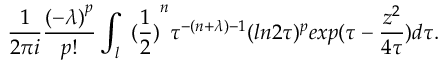Convert formula to latex. <formula><loc_0><loc_0><loc_500><loc_500>\frac { 1 } { 2 \pi i } \frac { { ( - \lambda ) } ^ { p } } { p ! } \int _ { l } { \ ( \frac { 1 } { 2 } ) } ^ { n } \tau ^ { - ( n + \lambda ) - 1 } ( \ln 2 \tau ) ^ { p } e x p ( \tau - \frac { z ^ { 2 } } { 4 \tau } ) d \tau .</formula> 